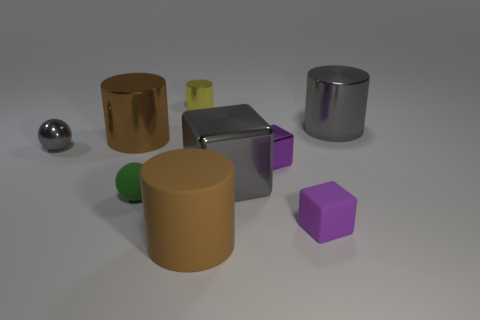How big is the gray shiny thing left of the brown rubber thing?
Keep it short and to the point. Small. Are there any other things of the same color as the big rubber object?
Keep it short and to the point. Yes. Is the brown metallic thing the same shape as the brown matte object?
Keep it short and to the point. Yes. What size is the cylinder that is in front of the big gray thing that is to the left of the big metallic cylinder right of the small cylinder?
Offer a terse response. Large. How many other objects are there of the same material as the yellow thing?
Ensure brevity in your answer.  5. What color is the rubber thing that is to the left of the yellow object?
Give a very brief answer. Green. What is the ball on the right side of the large cylinder on the left side of the big matte cylinder in front of the yellow cylinder made of?
Provide a short and direct response. Rubber. Are there any brown rubber things of the same shape as the tiny purple metallic object?
Your answer should be compact. No. What is the shape of the brown thing that is the same size as the brown rubber cylinder?
Provide a succinct answer. Cylinder. What number of gray metal objects are both on the right side of the purple rubber cube and left of the big gray block?
Your answer should be compact. 0. 